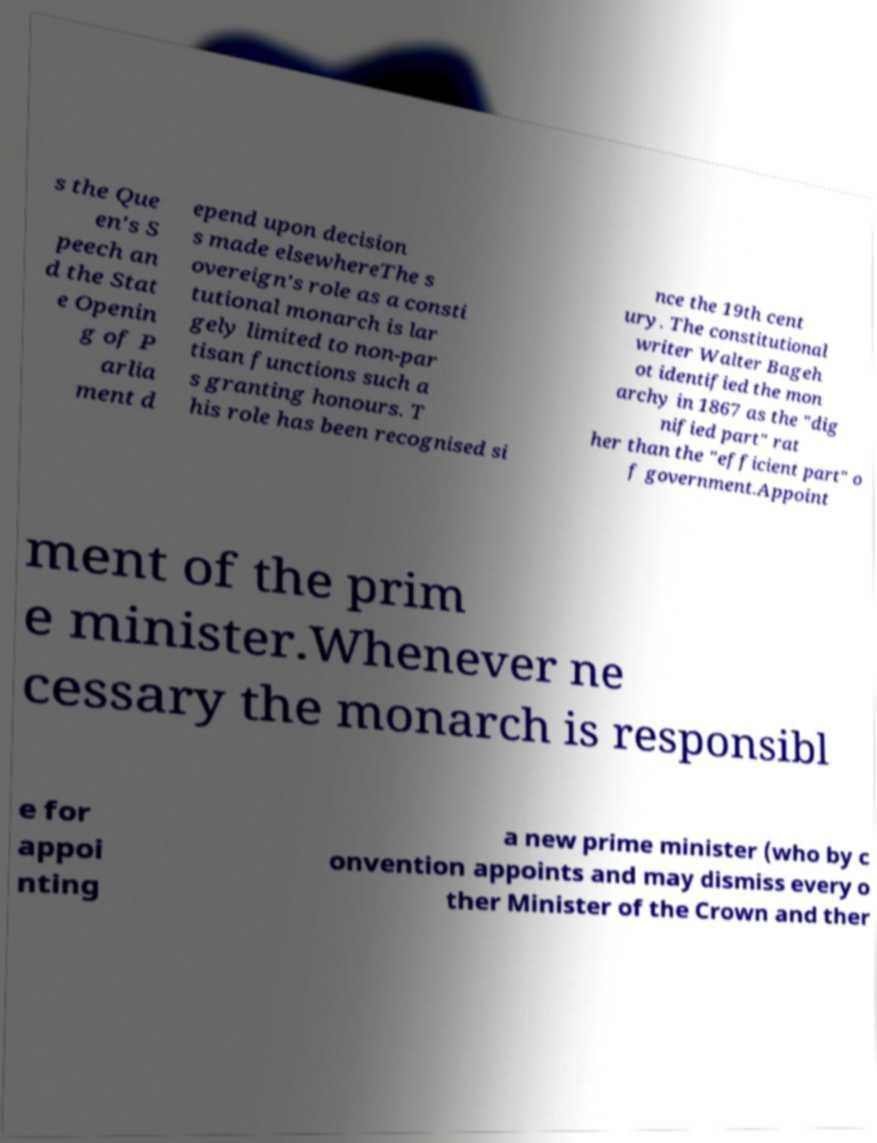There's text embedded in this image that I need extracted. Can you transcribe it verbatim? s the Que en's S peech an d the Stat e Openin g of P arlia ment d epend upon decision s made elsewhereThe s overeign's role as a consti tutional monarch is lar gely limited to non-par tisan functions such a s granting honours. T his role has been recognised si nce the 19th cent ury. The constitutional writer Walter Bageh ot identified the mon archy in 1867 as the "dig nified part" rat her than the "efficient part" o f government.Appoint ment of the prim e minister.Whenever ne cessary the monarch is responsibl e for appoi nting a new prime minister (who by c onvention appoints and may dismiss every o ther Minister of the Crown and ther 